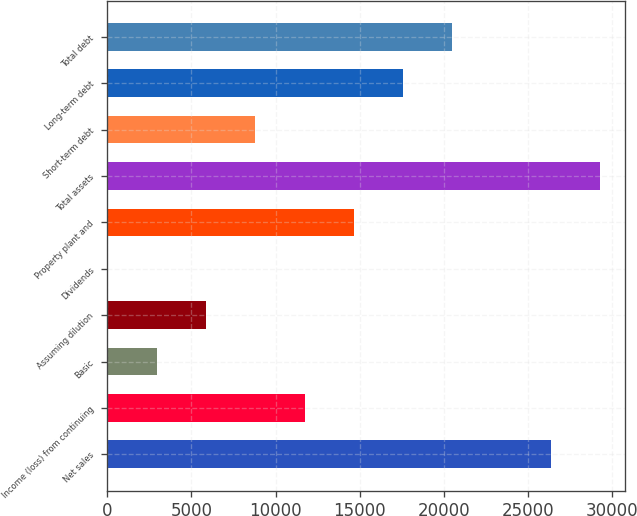<chart> <loc_0><loc_0><loc_500><loc_500><bar_chart><fcel>Net sales<fcel>Income (loss) from continuing<fcel>Basic<fcel>Assuming dilution<fcel>Dividends<fcel>Property plant and<fcel>Total assets<fcel>Short-term debt<fcel>Long-term debt<fcel>Total debt<nl><fcel>26382.7<fcel>11726.1<fcel>2932.08<fcel>5863.41<fcel>0.75<fcel>14657.4<fcel>29314<fcel>8794.74<fcel>17588.7<fcel>20520<nl></chart> 